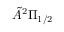Convert formula to latex. <formula><loc_0><loc_0><loc_500><loc_500>\tilde { A } ^ { 2 } \Pi _ { 1 / 2 }</formula> 